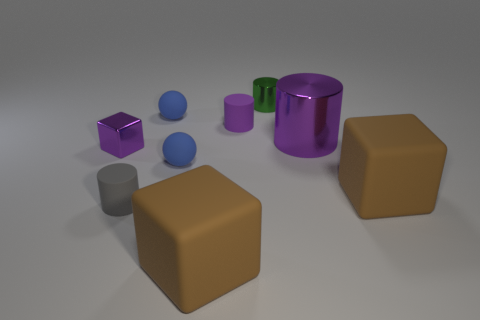Do the large brown thing on the left side of the green cylinder and the block that is to the right of the green cylinder have the same material?
Keep it short and to the point. Yes. What is the shape of the small thing that is both behind the small gray rubber object and in front of the tiny metallic cube?
Ensure brevity in your answer.  Sphere. Is there any other thing that is the same material as the small purple block?
Your answer should be compact. Yes. There is a purple object that is both in front of the small purple rubber cylinder and on the right side of the purple cube; what material is it made of?
Provide a short and direct response. Metal. The small object that is the same material as the green cylinder is what shape?
Offer a terse response. Cube. Is there any other thing of the same color as the large shiny cylinder?
Provide a succinct answer. Yes. Are there more large brown matte cubes in front of the tiny gray rubber object than purple rubber cylinders?
Your answer should be very brief. No. What material is the green cylinder?
Ensure brevity in your answer.  Metal. How many metallic cubes are the same size as the green metallic cylinder?
Offer a very short reply. 1. Are there an equal number of small rubber cylinders to the left of the purple metallic cylinder and large brown rubber blocks behind the small purple block?
Your response must be concise. No. 